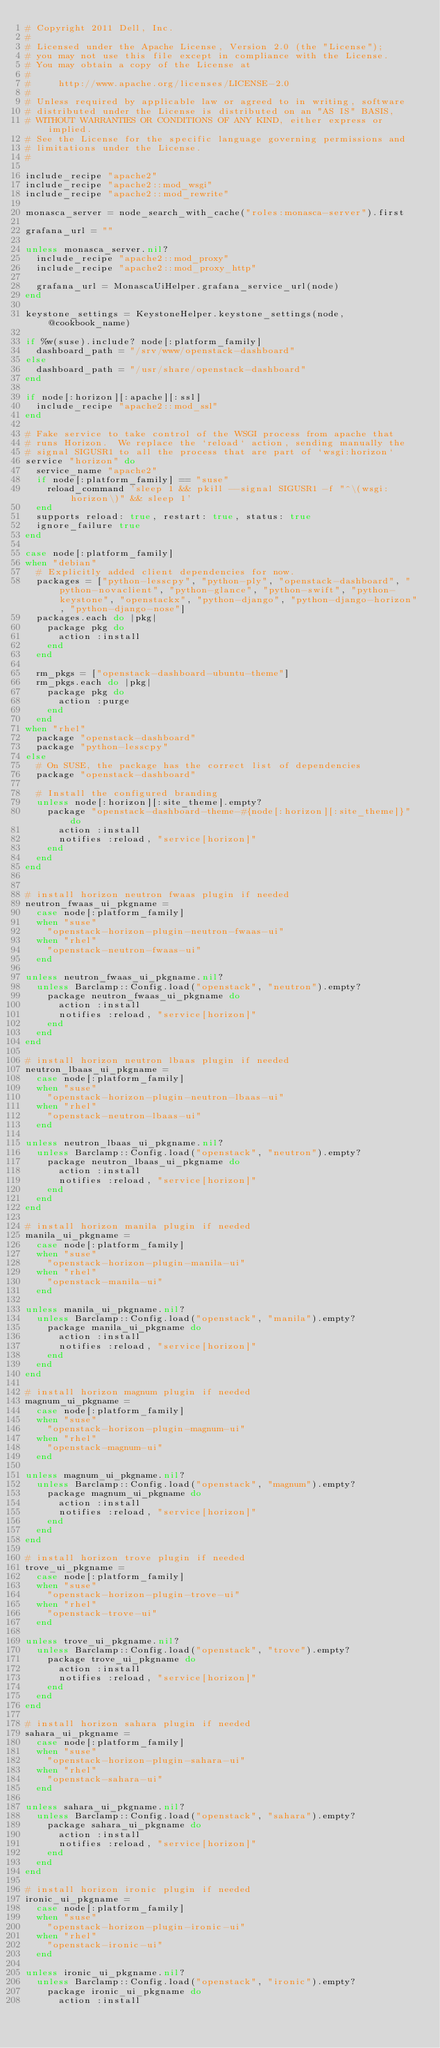Convert code to text. <code><loc_0><loc_0><loc_500><loc_500><_Ruby_># Copyright 2011 Dell, Inc.
#
# Licensed under the Apache License, Version 2.0 (the "License");
# you may not use this file except in compliance with the License.
# You may obtain a copy of the License at
#
#     http://www.apache.org/licenses/LICENSE-2.0
#
# Unless required by applicable law or agreed to in writing, software
# distributed under the License is distributed on an "AS IS" BASIS,
# WITHOUT WARRANTIES OR CONDITIONS OF ANY KIND, either express or implied.
# See the License for the specific language governing permissions and
# limitations under the License.
#

include_recipe "apache2"
include_recipe "apache2::mod_wsgi"
include_recipe "apache2::mod_rewrite"

monasca_server = node_search_with_cache("roles:monasca-server").first

grafana_url = ""

unless monasca_server.nil?
  include_recipe "apache2::mod_proxy"
  include_recipe "apache2::mod_proxy_http"

  grafana_url = MonascaUiHelper.grafana_service_url(node)
end

keystone_settings = KeystoneHelper.keystone_settings(node, @cookbook_name)

if %w(suse).include? node[:platform_family]
  dashboard_path = "/srv/www/openstack-dashboard"
else
  dashboard_path = "/usr/share/openstack-dashboard"
end

if node[:horizon][:apache][:ssl]
  include_recipe "apache2::mod_ssl"
end

# Fake service to take control of the WSGI process from apache that
# runs Horizon.  We replace the `reload` action, sending manually the
# signal SIGUSR1 to all the process that are part of `wsgi:horizon`
service "horizon" do
  service_name "apache2"
  if node[:platform_family] == "suse"
    reload_command 'sleep 1 && pkill --signal SIGUSR1 -f "^\(wsgi:horizon\)" && sleep 1'
  end
  supports reload: true, restart: true, status: true
  ignore_failure true
end

case node[:platform_family]
when "debian"
  # Explicitly added client dependencies for now.
  packages = ["python-lesscpy", "python-ply", "openstack-dashboard", "python-novaclient", "python-glance", "python-swift", "python-keystone", "openstackx", "python-django", "python-django-horizon", "python-django-nose"]
  packages.each do |pkg|
    package pkg do
      action :install
    end
  end

  rm_pkgs = ["openstack-dashboard-ubuntu-theme"]
  rm_pkgs.each do |pkg|
    package pkg do
      action :purge
    end
  end
when "rhel"
  package "openstack-dashboard"
  package "python-lesscpy"
else
  # On SUSE, the package has the correct list of dependencies
  package "openstack-dashboard"

  # Install the configured branding
  unless node[:horizon][:site_theme].empty?
    package "openstack-dashboard-theme-#{node[:horizon][:site_theme]}" do
      action :install
      notifies :reload, "service[horizon]"
    end
  end
end


# install horizon neutron fwaas plugin if needed
neutron_fwaas_ui_pkgname =
  case node[:platform_family]
  when "suse"
    "openstack-horizon-plugin-neutron-fwaas-ui"
  when "rhel"
    "openstack-neutron-fwaas-ui"
  end

unless neutron_fwaas_ui_pkgname.nil?
  unless Barclamp::Config.load("openstack", "neutron").empty?
    package neutron_fwaas_ui_pkgname do
      action :install
      notifies :reload, "service[horizon]"
    end
  end
end

# install horizon neutron lbaas plugin if needed
neutron_lbaas_ui_pkgname =
  case node[:platform_family]
  when "suse"
    "openstack-horizon-plugin-neutron-lbaas-ui"
  when "rhel"
    "openstack-neutron-lbaas-ui"
  end

unless neutron_lbaas_ui_pkgname.nil?
  unless Barclamp::Config.load("openstack", "neutron").empty?
    package neutron_lbaas_ui_pkgname do
      action :install
      notifies :reload, "service[horizon]"
    end
  end
end

# install horizon manila plugin if needed
manila_ui_pkgname =
  case node[:platform_family]
  when "suse"
    "openstack-horizon-plugin-manila-ui"
  when "rhel"
    "openstack-manila-ui"
  end

unless manila_ui_pkgname.nil?
  unless Barclamp::Config.load("openstack", "manila").empty?
    package manila_ui_pkgname do
      action :install
      notifies :reload, "service[horizon]"
    end
  end
end

# install horizon magnum plugin if needed
magnum_ui_pkgname =
  case node[:platform_family]
  when "suse"
    "openstack-horizon-plugin-magnum-ui"
  when "rhel"
    "openstack-magnum-ui"
  end

unless magnum_ui_pkgname.nil?
  unless Barclamp::Config.load("openstack", "magnum").empty?
    package magnum_ui_pkgname do
      action :install
      notifies :reload, "service[horizon]"
    end
  end
end

# install horizon trove plugin if needed
trove_ui_pkgname =
  case node[:platform_family]
  when "suse"
    "openstack-horizon-plugin-trove-ui"
  when "rhel"
    "openstack-trove-ui"
  end

unless trove_ui_pkgname.nil?
  unless Barclamp::Config.load("openstack", "trove").empty?
    package trove_ui_pkgname do
      action :install
      notifies :reload, "service[horizon]"
    end
  end
end

# install horizon sahara plugin if needed
sahara_ui_pkgname =
  case node[:platform_family]
  when "suse"
    "openstack-horizon-plugin-sahara-ui"
  when "rhel"
    "openstack-sahara-ui"
  end

unless sahara_ui_pkgname.nil?
  unless Barclamp::Config.load("openstack", "sahara").empty?
    package sahara_ui_pkgname do
      action :install
      notifies :reload, "service[horizon]"
    end
  end
end

# install horizon ironic plugin if needed
ironic_ui_pkgname =
  case node[:platform_family]
  when "suse"
    "openstack-horizon-plugin-ironic-ui"
  when "rhel"
    "openstack-ironic-ui"
  end

unless ironic_ui_pkgname.nil?
  unless Barclamp::Config.load("openstack", "ironic").empty?
    package ironic_ui_pkgname do
      action :install</code> 